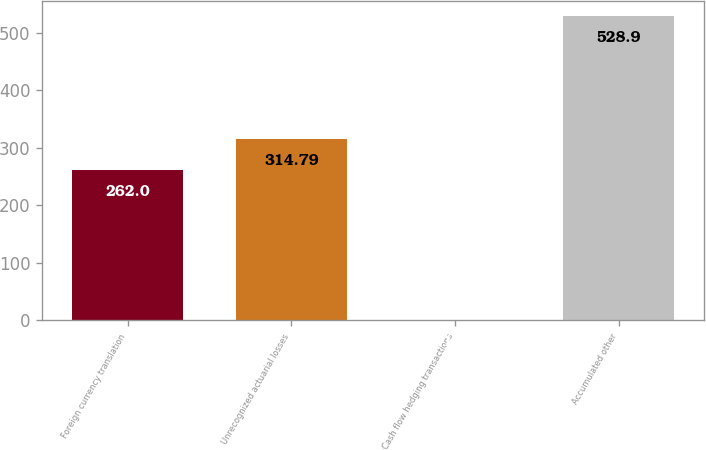<chart> <loc_0><loc_0><loc_500><loc_500><bar_chart><fcel>Foreign currency translation<fcel>Unrecognized actuarial losses<fcel>Cash flow hedging transactions<fcel>Accumulated other<nl><fcel>262<fcel>314.79<fcel>1<fcel>528.9<nl></chart> 